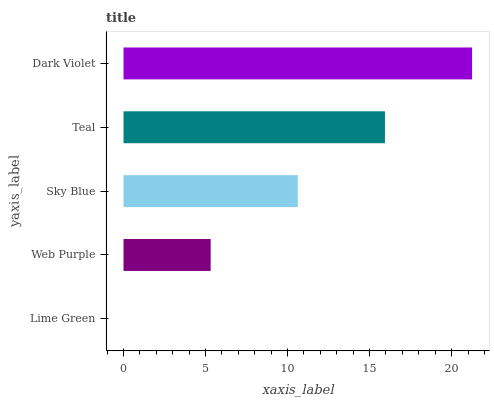Is Lime Green the minimum?
Answer yes or no. Yes. Is Dark Violet the maximum?
Answer yes or no. Yes. Is Web Purple the minimum?
Answer yes or no. No. Is Web Purple the maximum?
Answer yes or no. No. Is Web Purple greater than Lime Green?
Answer yes or no. Yes. Is Lime Green less than Web Purple?
Answer yes or no. Yes. Is Lime Green greater than Web Purple?
Answer yes or no. No. Is Web Purple less than Lime Green?
Answer yes or no. No. Is Sky Blue the high median?
Answer yes or no. Yes. Is Sky Blue the low median?
Answer yes or no. Yes. Is Lime Green the high median?
Answer yes or no. No. Is Dark Violet the low median?
Answer yes or no. No. 